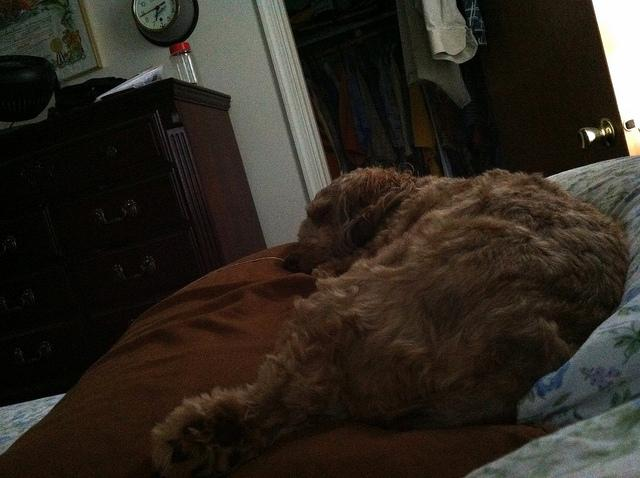What is on the bed? dog 